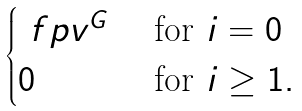Convert formula to latex. <formula><loc_0><loc_0><loc_500><loc_500>\begin{cases} \ f p v ^ { G } & \text { for } i = 0 \\ 0 & \text { for } i \geq 1 . \end{cases}</formula> 